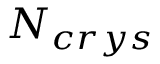Convert formula to latex. <formula><loc_0><loc_0><loc_500><loc_500>N _ { c r y s }</formula> 